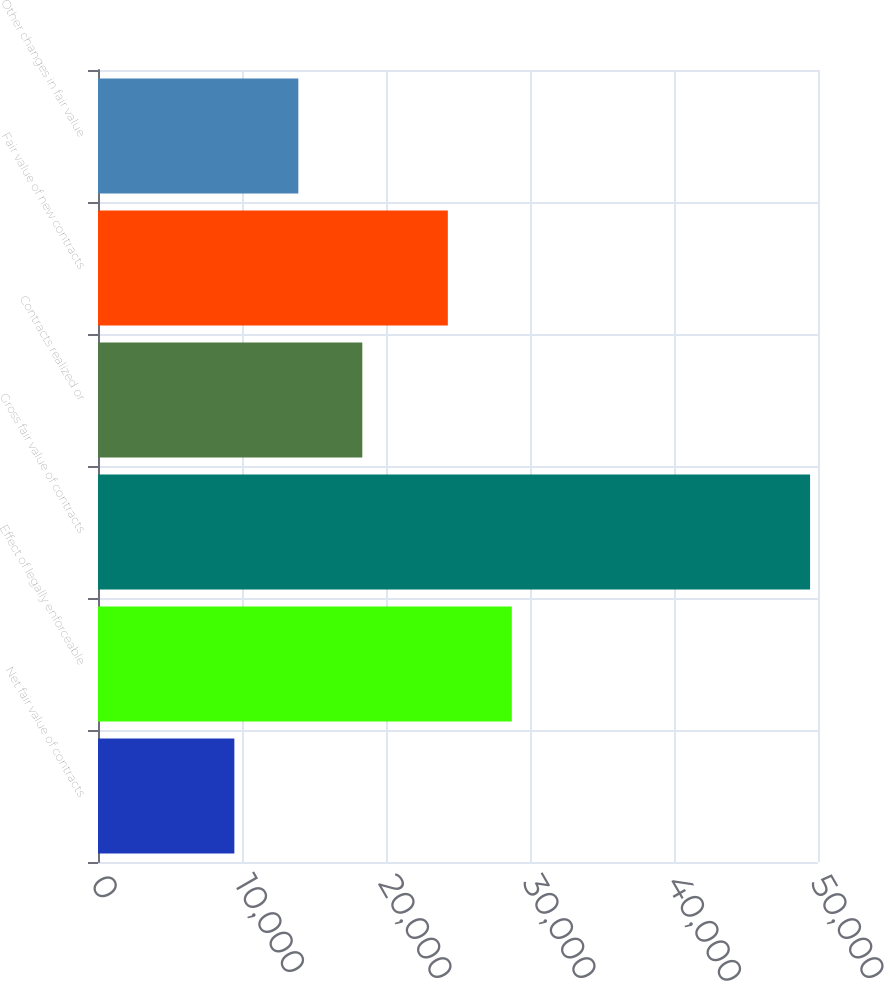Convert chart to OTSL. <chart><loc_0><loc_0><loc_500><loc_500><bar_chart><fcel>Net fair value of contracts<fcel>Effect of legally enforceable<fcel>Gross fair value of contracts<fcel>Contracts realized or<fcel>Fair value of new contracts<fcel>Other changes in fair value<nl><fcel>9469.3<fcel>28736.3<fcel>49450<fcel>18353.9<fcel>24294<fcel>13911.6<nl></chart> 